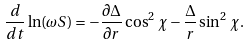Convert formula to latex. <formula><loc_0><loc_0><loc_500><loc_500>\frac { d } { d t } \ln ( \omega S ) = - \frac { \partial \Delta } { \partial r } \cos ^ { 2 } \, \chi - \frac { \Delta } { r } \sin ^ { 2 } \, \chi .</formula> 